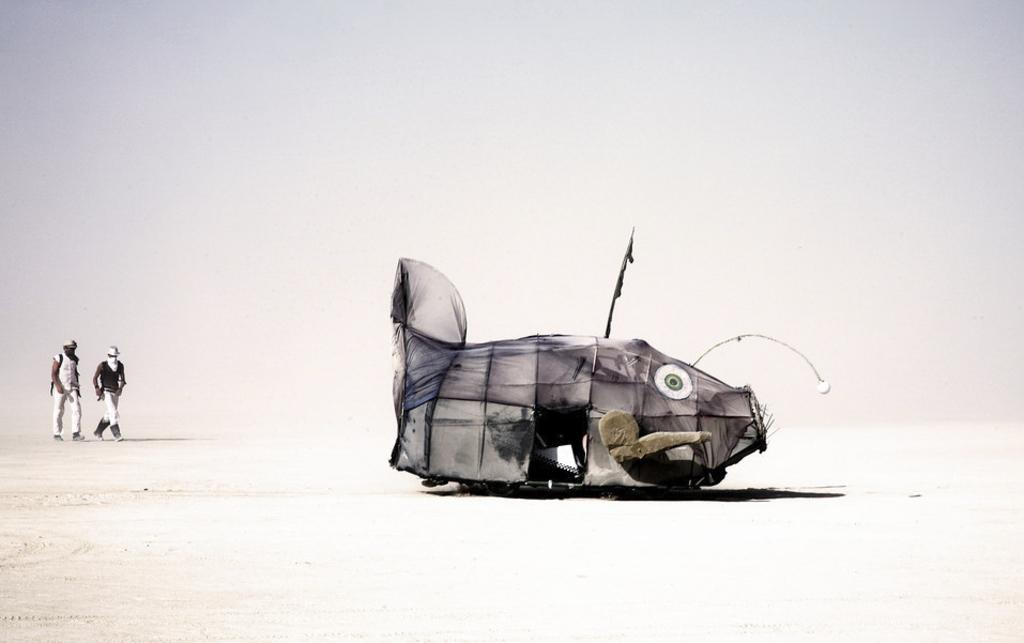What is happening on the left side of the image? There are people walking on the left side of the image. Can you describe the tent house in the image? The tent house is in the shape of a fish. What type of wax can be seen melting on the tent house in the image? There is no wax present in the image, and therefore no wax can be seen melting on the tent house. What kind of insect is crawling on the people walking on the left side of the image? There is no insect present in the image, and therefore no insect can be seen crawling on the people walking on the left side of the image. 